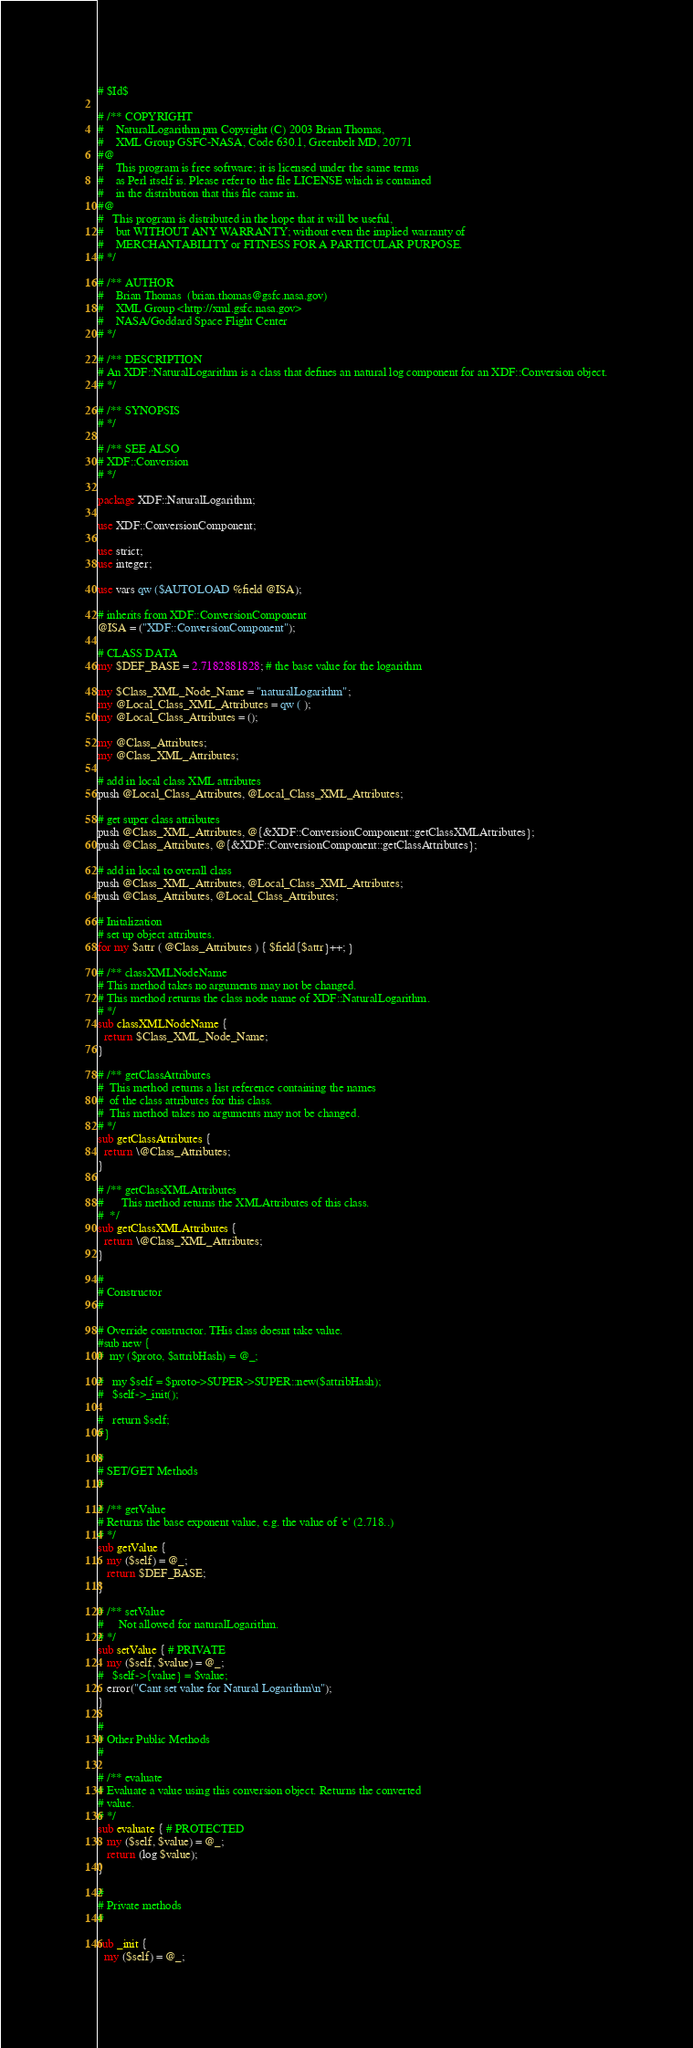Convert code to text. <code><loc_0><loc_0><loc_500><loc_500><_Perl_>
# $Id$

# /** COPYRIGHT
#    NaturalLogarithm.pm Copyright (C) 2003 Brian Thomas,
#    XML Group GSFC-NASA, Code 630.1, Greenbelt MD, 20771
#@ 
#    This program is free software; it is licensed under the same terms
#    as Perl itself is. Please refer to the file LICENSE which is contained
#    in the distribution that this file came in.
#@ 
#   This program is distributed in the hope that it will be useful,
#    but WITHOUT ANY WARRANTY; without even the implied warranty of
#    MERCHANTABILITY or FITNESS FOR A PARTICULAR PURPOSE.  
# */

# /** AUTHOR
#    Brian Thomas  (brian.thomas@gsfc.nasa.gov)
#    XML Group <http://xml.gsfc.nasa.gov>
#    NASA/Goddard Space Flight Center
# */

# /** DESCRIPTION
# An XDF::NaturalLogarithm is a class that defines an natural log component for an XDF::Conversion object.
# */

# /** SYNOPSIS
# */

# /** SEE ALSO
# XDF::Conversion
# */

package XDF::NaturalLogarithm;

use XDF::ConversionComponent;

use strict;
use integer;

use vars qw ($AUTOLOAD %field @ISA);

# inherits from XDF::ConversionComponent
@ISA = ("XDF::ConversionComponent");

# CLASS DATA
my $DEF_BASE = 2.7182881828; # the base value for the logarithm 

my $Class_XML_Node_Name = "naturalLogarithm";
my @Local_Class_XML_Attributes = qw ( );
my @Local_Class_Attributes = ();

my @Class_Attributes;
my @Class_XML_Attributes;

# add in local class XML attributes
push @Local_Class_Attributes, @Local_Class_XML_Attributes;

# get super class attributes
push @Class_XML_Attributes, @{&XDF::ConversionComponent::getClassXMLAttributes};
push @Class_Attributes, @{&XDF::ConversionComponent::getClassAttributes};

# add in local to overall class
push @Class_XML_Attributes, @Local_Class_XML_Attributes;
push @Class_Attributes, @Local_Class_Attributes;

# Initalization
# set up object attributes.
for my $attr ( @Class_Attributes ) { $field{$attr}++; }

# /** classXMLNodeName
# This method takes no arguments may not be changed. 
# This method returns the class node name of XDF::NaturalLogarithm.
# */
sub classXMLNodeName { 
  return $Class_XML_Node_Name; 
}

# /** getClassAttributes
#  This method returns a list reference containing the names
#  of the class attributes for this class.
#  This method takes no arguments may not be changed. 
# */
sub getClassAttributes {
  return \@Class_Attributes;
}

# /** getClassXMLAttributes
#      This method returns the XMLAttributes of this class. 
#  */
sub getClassXMLAttributes {
  return \@Class_XML_Attributes;
}

#
# Constructor
#

# Override constructor. THis class doesnt take value.
#sub new {
#  my ($proto, $attribHash) = @_;

#   my $self = $proto->SUPER->SUPER::new($attribHash);
#   $self->_init();

#   return $self;
#}

# 
# SET/GET Methods
#

# /** getValue
# Returns the base exponent value, e.g. the value of 'e' (2.718..)
# */
sub getValue { 
   my ($self) = @_;
   return $DEF_BASE;
}

# /** setValue
#     Not allowed for naturalLogarithm. 
# */
sub setValue { # PRIVATE
   my ($self, $value) = @_;
#   $self->{value} = $value;
   error("Cant set value for Natural Logarithm\n"); 
}

#
# Other Public Methods
#

# /** evaluate
# Evaluate a value using this conversion object. Returns the converted
# value.
# */
sub evaluate { # PROTECTED
   my ($self, $value) = @_;
   return (log $value);
}

#
# Private methods 
#

sub _init {
  my ($self) = @_;</code> 